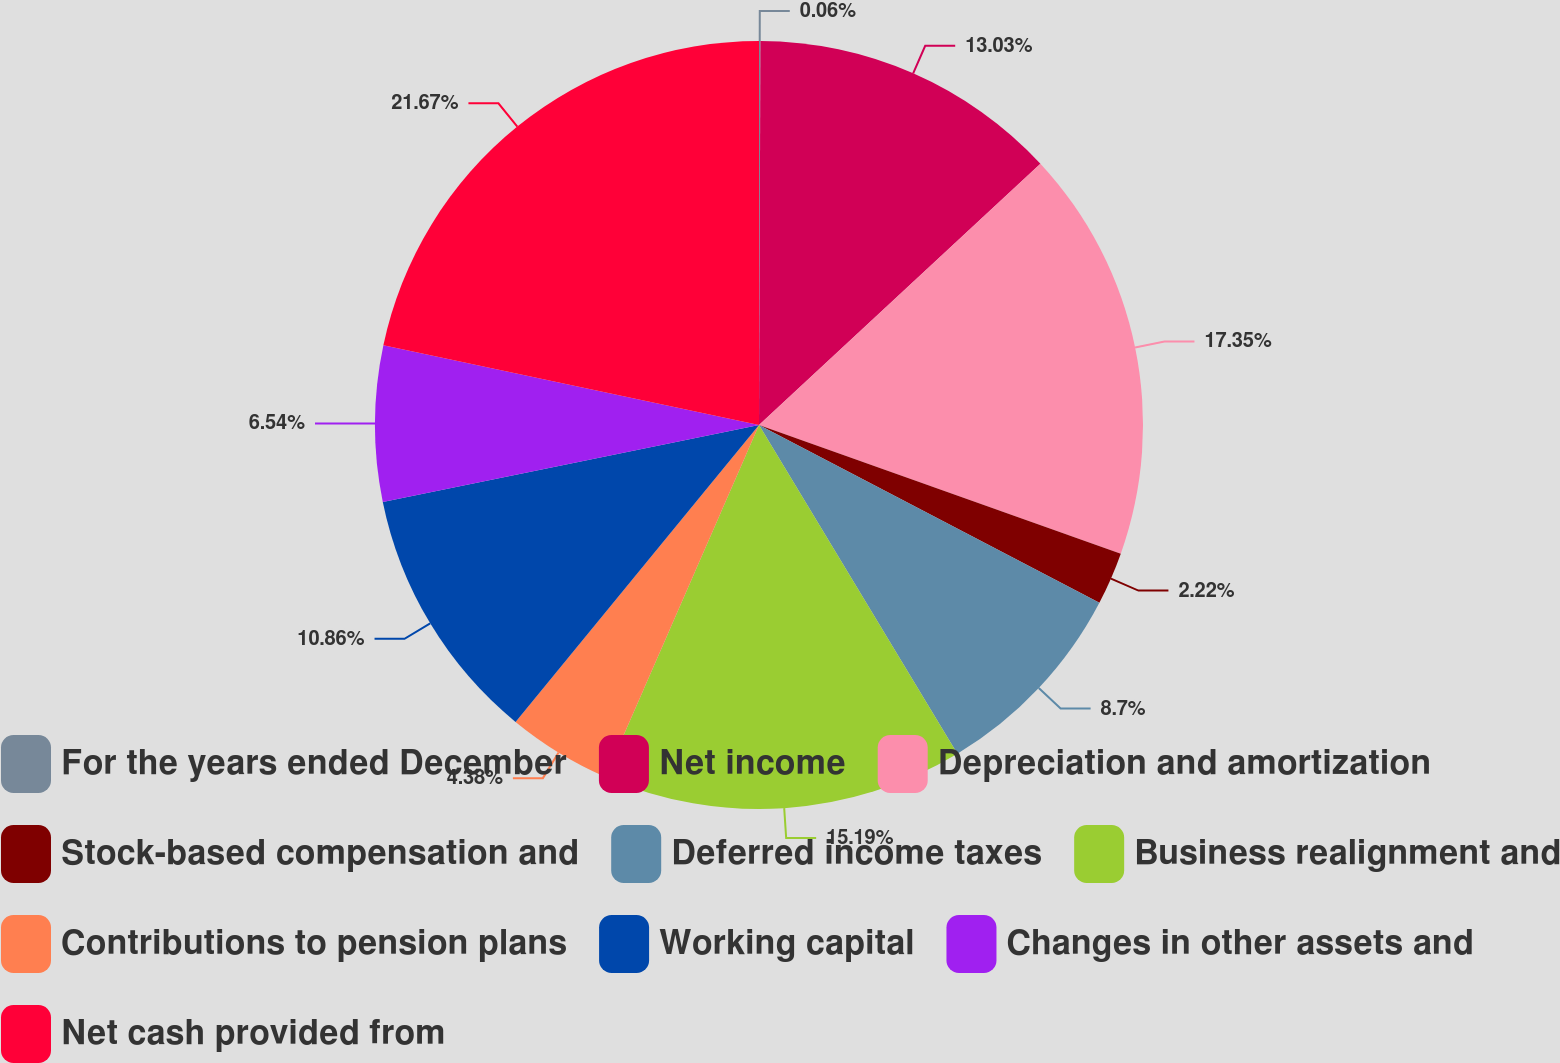Convert chart to OTSL. <chart><loc_0><loc_0><loc_500><loc_500><pie_chart><fcel>For the years ended December<fcel>Net income<fcel>Depreciation and amortization<fcel>Stock-based compensation and<fcel>Deferred income taxes<fcel>Business realignment and<fcel>Contributions to pension plans<fcel>Working capital<fcel>Changes in other assets and<fcel>Net cash provided from<nl><fcel>0.06%<fcel>13.03%<fcel>17.35%<fcel>2.22%<fcel>8.7%<fcel>15.19%<fcel>4.38%<fcel>10.86%<fcel>6.54%<fcel>21.67%<nl></chart> 